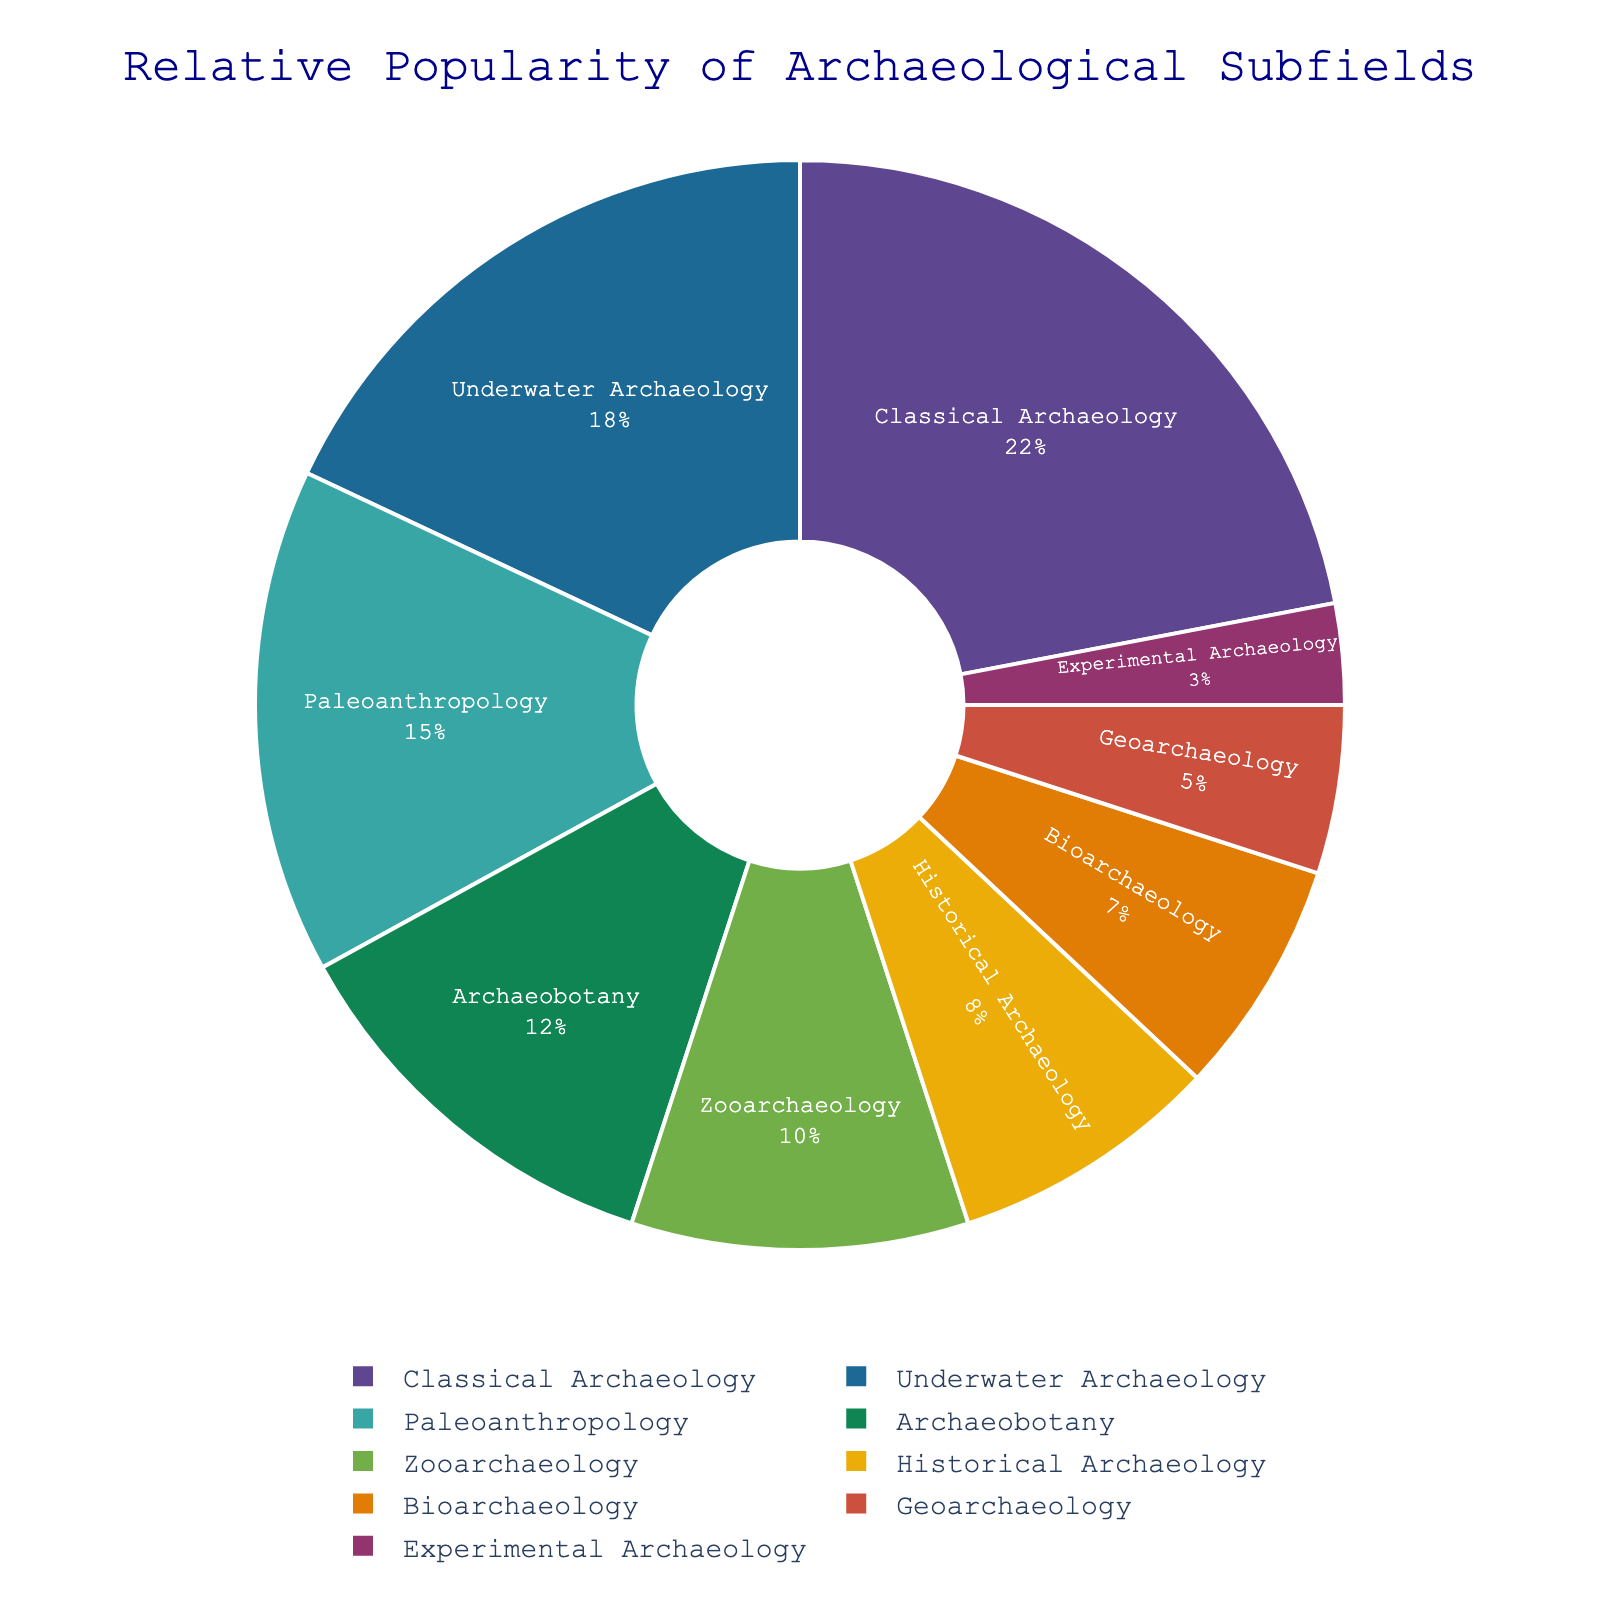Which archaeological subfield is the most popular? The figure clearly shows the relative popularity of each subfield by size and percentage. The largest section of the pie chart represents "Classical Archaeology" with 22%.
Answer: Classical Archaeology Which subfield is less popular: Archaeobotany or Bioarchaeology? By examining the pie chart, we can see that "Archaeobotany" is represented by a larger section than "Bioarchaeology." Specifically, Archaeobotany accounts for 12%, while Bioarchaeology accounts for 7%.
Answer: Bioarchaeology What is the combined percentage of students interested in Paleoanthropology and Archaeobotany? To find the combined percentage, add the percentage for each subfield: Paleoanthropology (15%) + Archaeobotany (12%) = 27%.
Answer: 27% Which subfields are equally popular? By examining the provided percentages and comparing the sizes of the sections in the pie chart, no two subfields have the same percentage; thus, none are equally popular.
Answer: None How does Historical Archaeology's popularity compare to Geoarchaeology? By looking at the pie chart, we can see the percentage for Historical Archaeology (8%) is greater than Geoarchaeology (5%).
Answer: Higher What percentage of students are interested in subfields other than Classical Archaeology? Subtract the percentage for Classical Archaeology from 100%. That is, 100% - 22% = 78%.
Answer: 78% What's the difference in popularity between Underwater Archaeology and Experimental Archaeology? We calculate the difference by subtracting the percentage for Experimental Archaeology from Underwater Archaeology: 18% - 3% = 15%.
Answer: 15% What is the total percentage for the four least popular subfields? Add the percentage for each subfield: Experimental Archaeology (3%) + Geoarchaeology (5%) + Bioarchaeology (7%) + Historical Archaeology (8%) = 23%.
Answer: 23% Which subfield is more popular, Zooarchaeology or Historical Archaeology? By examining the pie chart, we see Zooarchaeology accounts for 10%, while Historical Archaeology accounts for 8%, indicating Zooarchaeology is more popular.
Answer: Zooarchaeology 